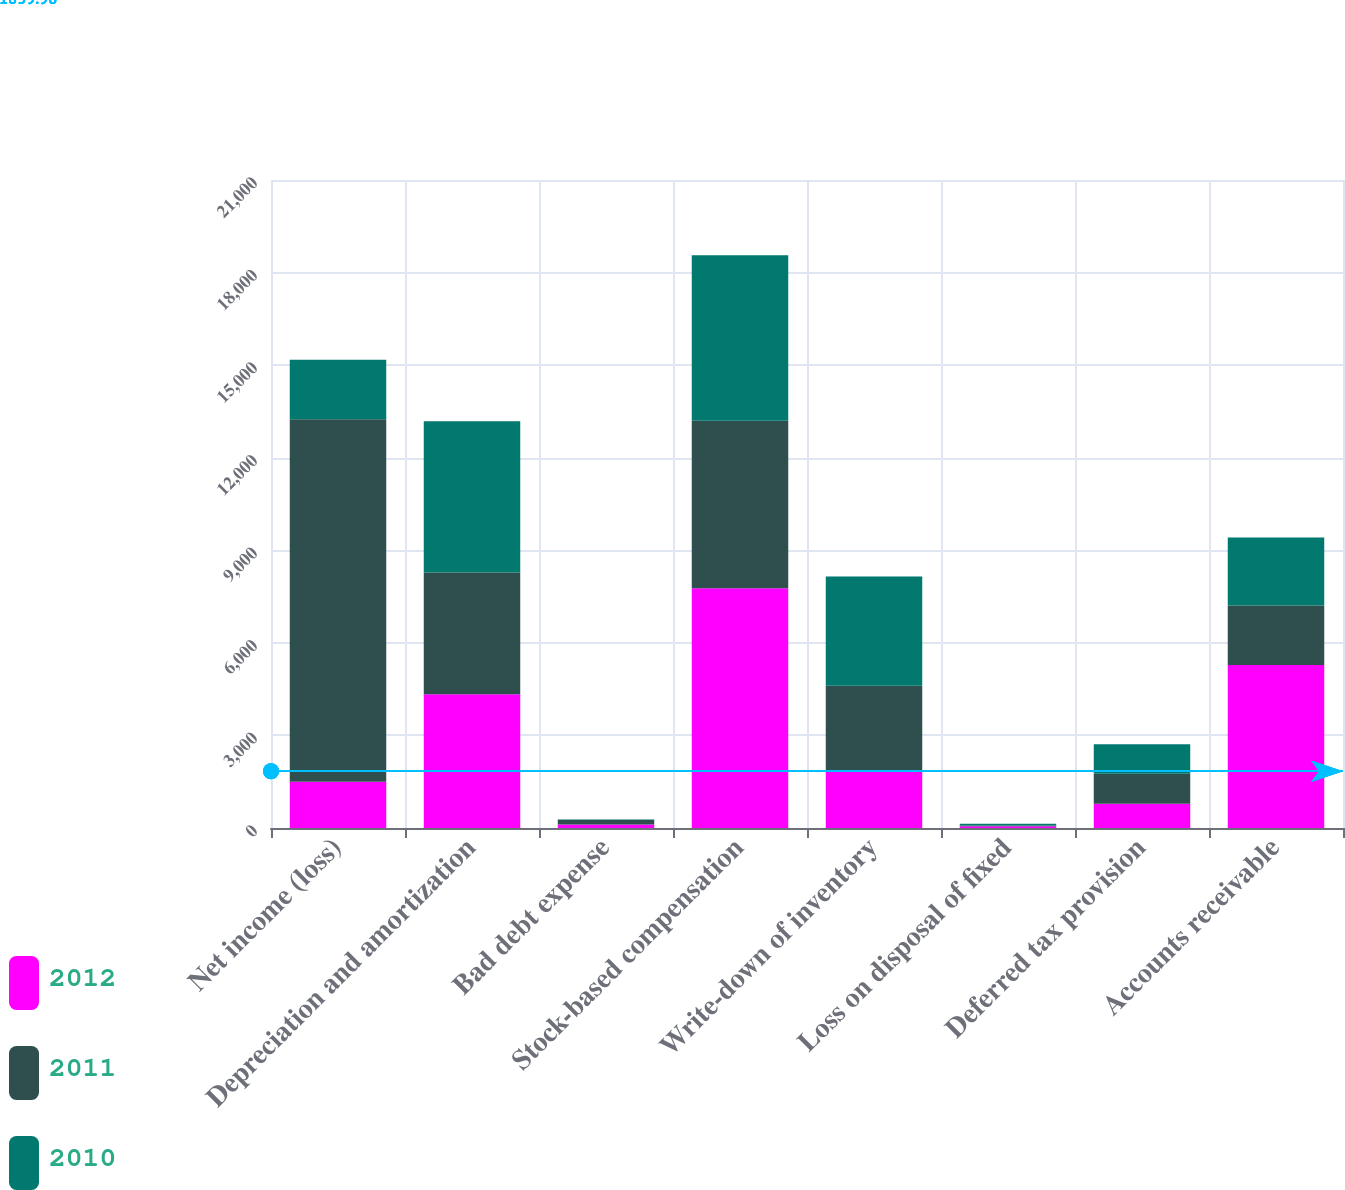<chart> <loc_0><loc_0><loc_500><loc_500><stacked_bar_chart><ecel><fcel>Net income (loss)<fcel>Depreciation and amortization<fcel>Bad debt expense<fcel>Stock-based compensation<fcel>Write-down of inventory<fcel>Loss on disposal of fixed<fcel>Deferred tax provision<fcel>Accounts receivable<nl><fcel>2012<fcel>1495<fcel>4336<fcel>117<fcel>7773<fcel>1833<fcel>53<fcel>789<fcel>5284<nl><fcel>2011<fcel>11755<fcel>3948<fcel>139<fcel>5421<fcel>2781<fcel>29<fcel>970<fcel>1923<nl><fcel>2010<fcel>1923<fcel>4898<fcel>22<fcel>5365<fcel>3536<fcel>54<fcel>954<fcel>2210<nl></chart> 